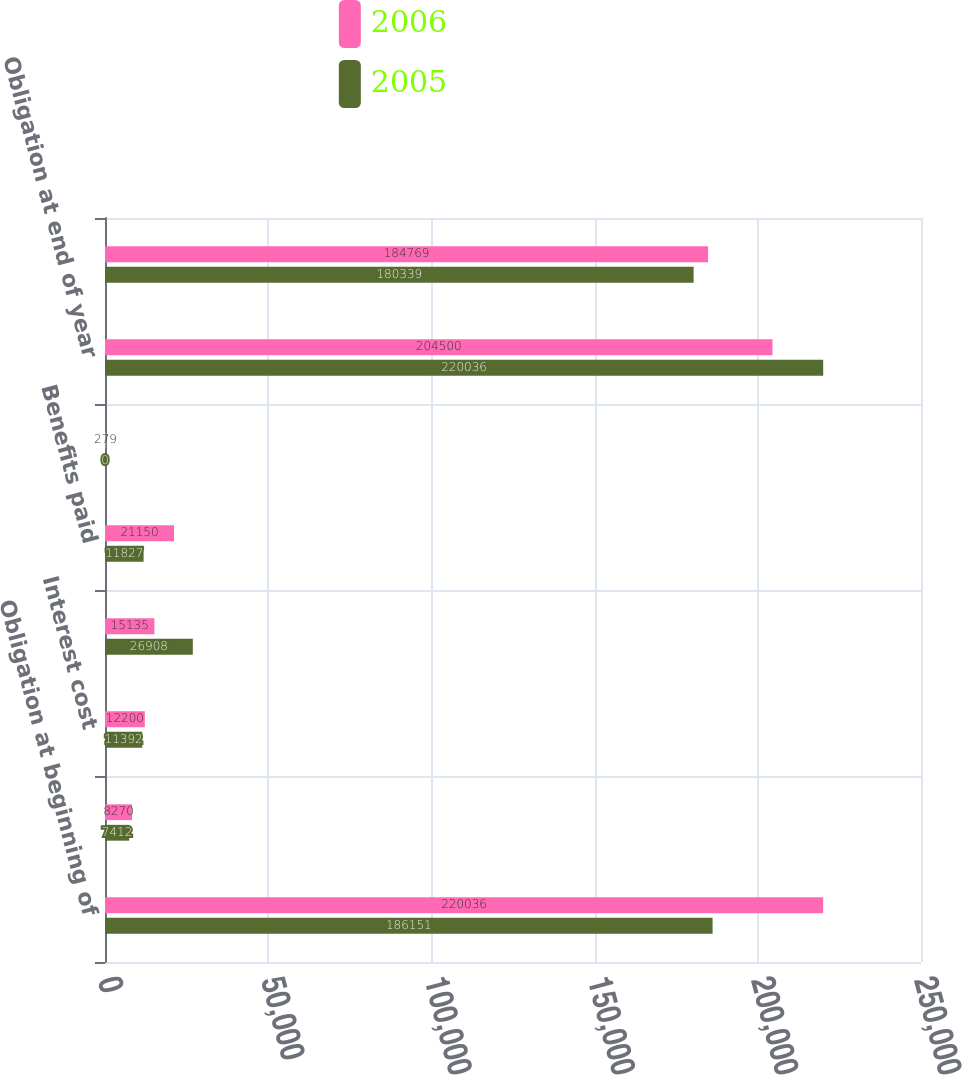Convert chart. <chart><loc_0><loc_0><loc_500><loc_500><stacked_bar_chart><ecel><fcel>Obligation at beginning of<fcel>Service cost<fcel>Interest cost<fcel>Actuarial loss (gain)<fcel>Benefits paid<fcel>Plan amendments<fcel>Obligation at end of year<fcel>Fair value at beginning of<nl><fcel>2006<fcel>220036<fcel>8270<fcel>12200<fcel>15135<fcel>21150<fcel>279<fcel>204500<fcel>184769<nl><fcel>2005<fcel>186151<fcel>7412<fcel>11392<fcel>26908<fcel>11827<fcel>0<fcel>220036<fcel>180339<nl></chart> 